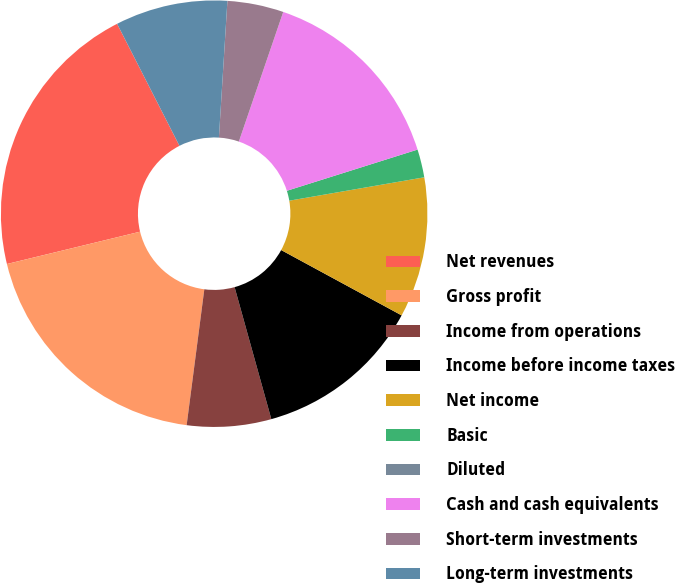Convert chart. <chart><loc_0><loc_0><loc_500><loc_500><pie_chart><fcel>Net revenues<fcel>Gross profit<fcel>Income from operations<fcel>Income before income taxes<fcel>Net income<fcel>Basic<fcel>Diluted<fcel>Cash and cash equivalents<fcel>Short-term investments<fcel>Long-term investments<nl><fcel>21.27%<fcel>19.15%<fcel>6.38%<fcel>12.77%<fcel>10.64%<fcel>2.13%<fcel>0.0%<fcel>14.89%<fcel>4.26%<fcel>8.51%<nl></chart> 